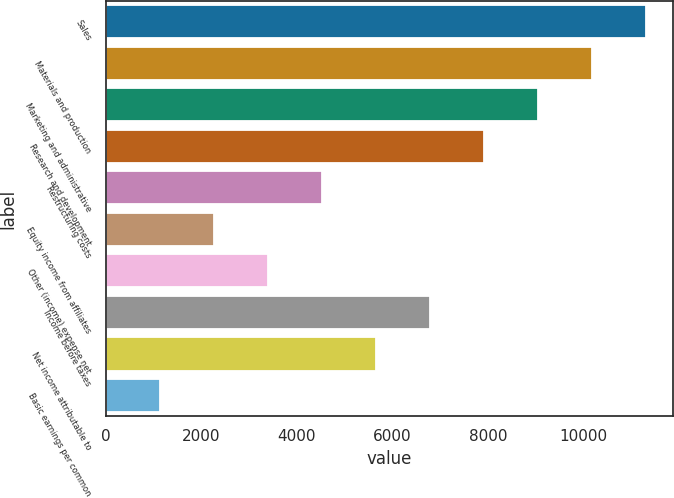<chart> <loc_0><loc_0><loc_500><loc_500><bar_chart><fcel>Sales<fcel>Materials and production<fcel>Marketing and administrative<fcel>Research and development<fcel>Restructuring costs<fcel>Equity income from affiliates<fcel>Other (income) expense net<fcel>Income before taxes<fcel>Net income attributable to<fcel>Basic earnings per common<nl><fcel>11319<fcel>10187.1<fcel>9055.22<fcel>7923.35<fcel>4527.74<fcel>2264<fcel>3395.87<fcel>6791.48<fcel>5659.61<fcel>1132.13<nl></chart> 